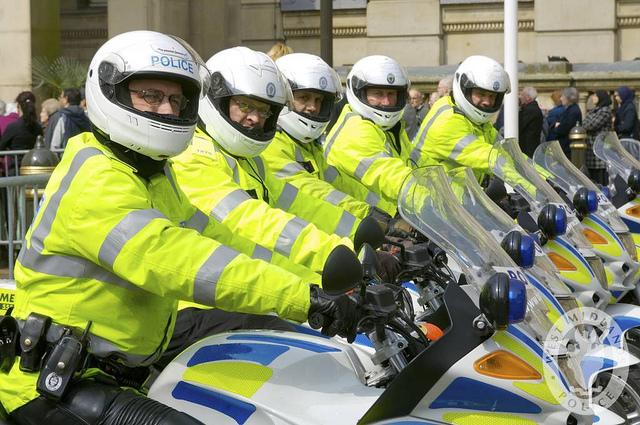Why do they wear helmets?
Keep it brief. Safety. Is it cold outside?
Write a very short answer. Yes. Is the crowd looking at the police?
Concise answer only. No. What are the men riding?
Short answer required. Motorcycles. 